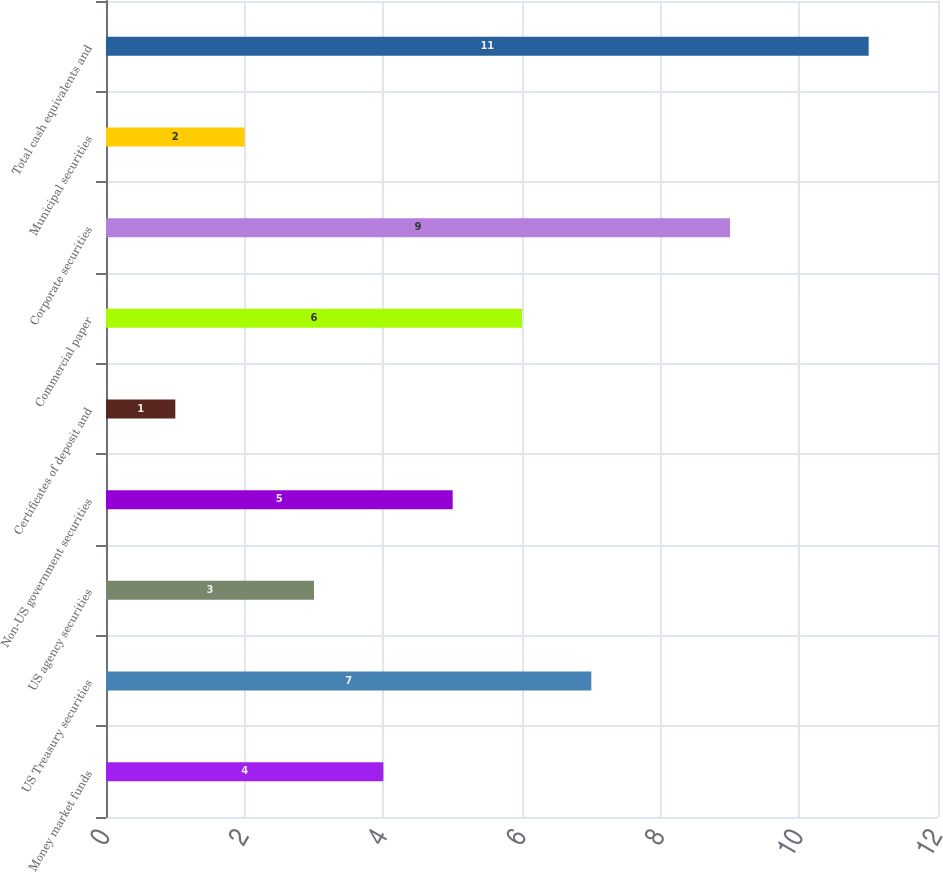<chart> <loc_0><loc_0><loc_500><loc_500><bar_chart><fcel>Money market funds<fcel>US Treasury securities<fcel>US agency securities<fcel>Non-US government securities<fcel>Certificates of deposit and<fcel>Commercial paper<fcel>Corporate securities<fcel>Municipal securities<fcel>Total cash equivalents and<nl><fcel>4<fcel>7<fcel>3<fcel>5<fcel>1<fcel>6<fcel>9<fcel>2<fcel>11<nl></chart> 